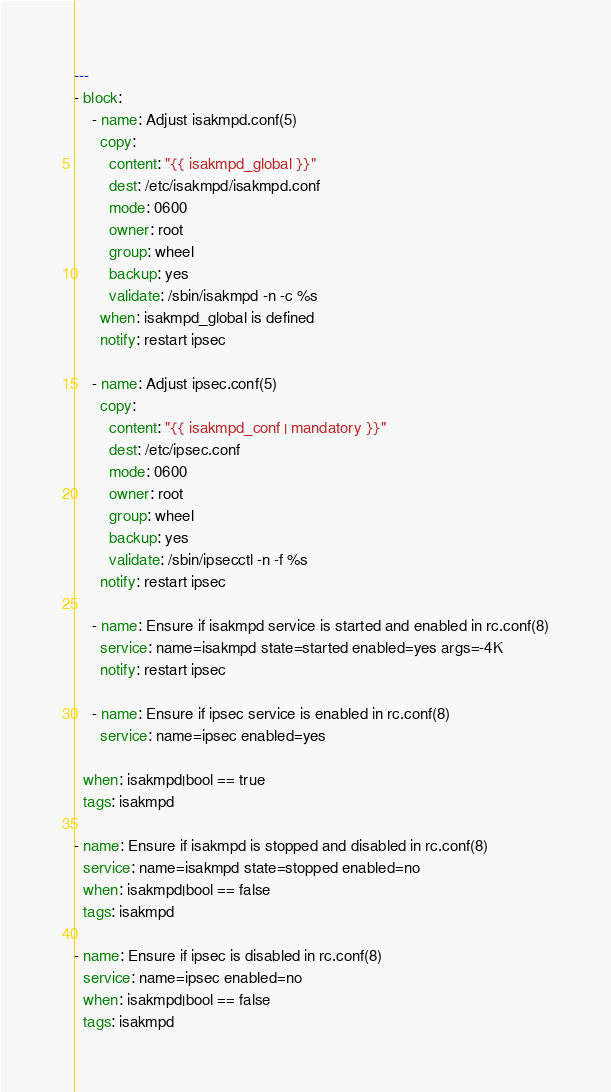Convert code to text. <code><loc_0><loc_0><loc_500><loc_500><_YAML_>---
- block:
    - name: Adjust isakmpd.conf(5)
      copy:
        content: "{{ isakmpd_global }}"
        dest: /etc/isakmpd/isakmpd.conf
        mode: 0600
        owner: root
        group: wheel
        backup: yes
        validate: /sbin/isakmpd -n -c %s
      when: isakmpd_global is defined
      notify: restart ipsec

    - name: Adjust ipsec.conf(5)
      copy:
        content: "{{ isakmpd_conf | mandatory }}"
        dest: /etc/ipsec.conf
        mode: 0600
        owner: root
        group: wheel
        backup: yes
        validate: /sbin/ipsecctl -n -f %s
      notify: restart ipsec

    - name: Ensure if isakmpd service is started and enabled in rc.conf(8)
      service: name=isakmpd state=started enabled=yes args=-4K
      notify: restart ipsec

    - name: Ensure if ipsec service is enabled in rc.conf(8)
      service: name=ipsec enabled=yes

  when: isakmpd|bool == true
  tags: isakmpd

- name: Ensure if isakmpd is stopped and disabled in rc.conf(8)
  service: name=isakmpd state=stopped enabled=no
  when: isakmpd|bool == false
  tags: isakmpd

- name: Ensure if ipsec is disabled in rc.conf(8)
  service: name=ipsec enabled=no
  when: isakmpd|bool == false
  tags: isakmpd
</code> 